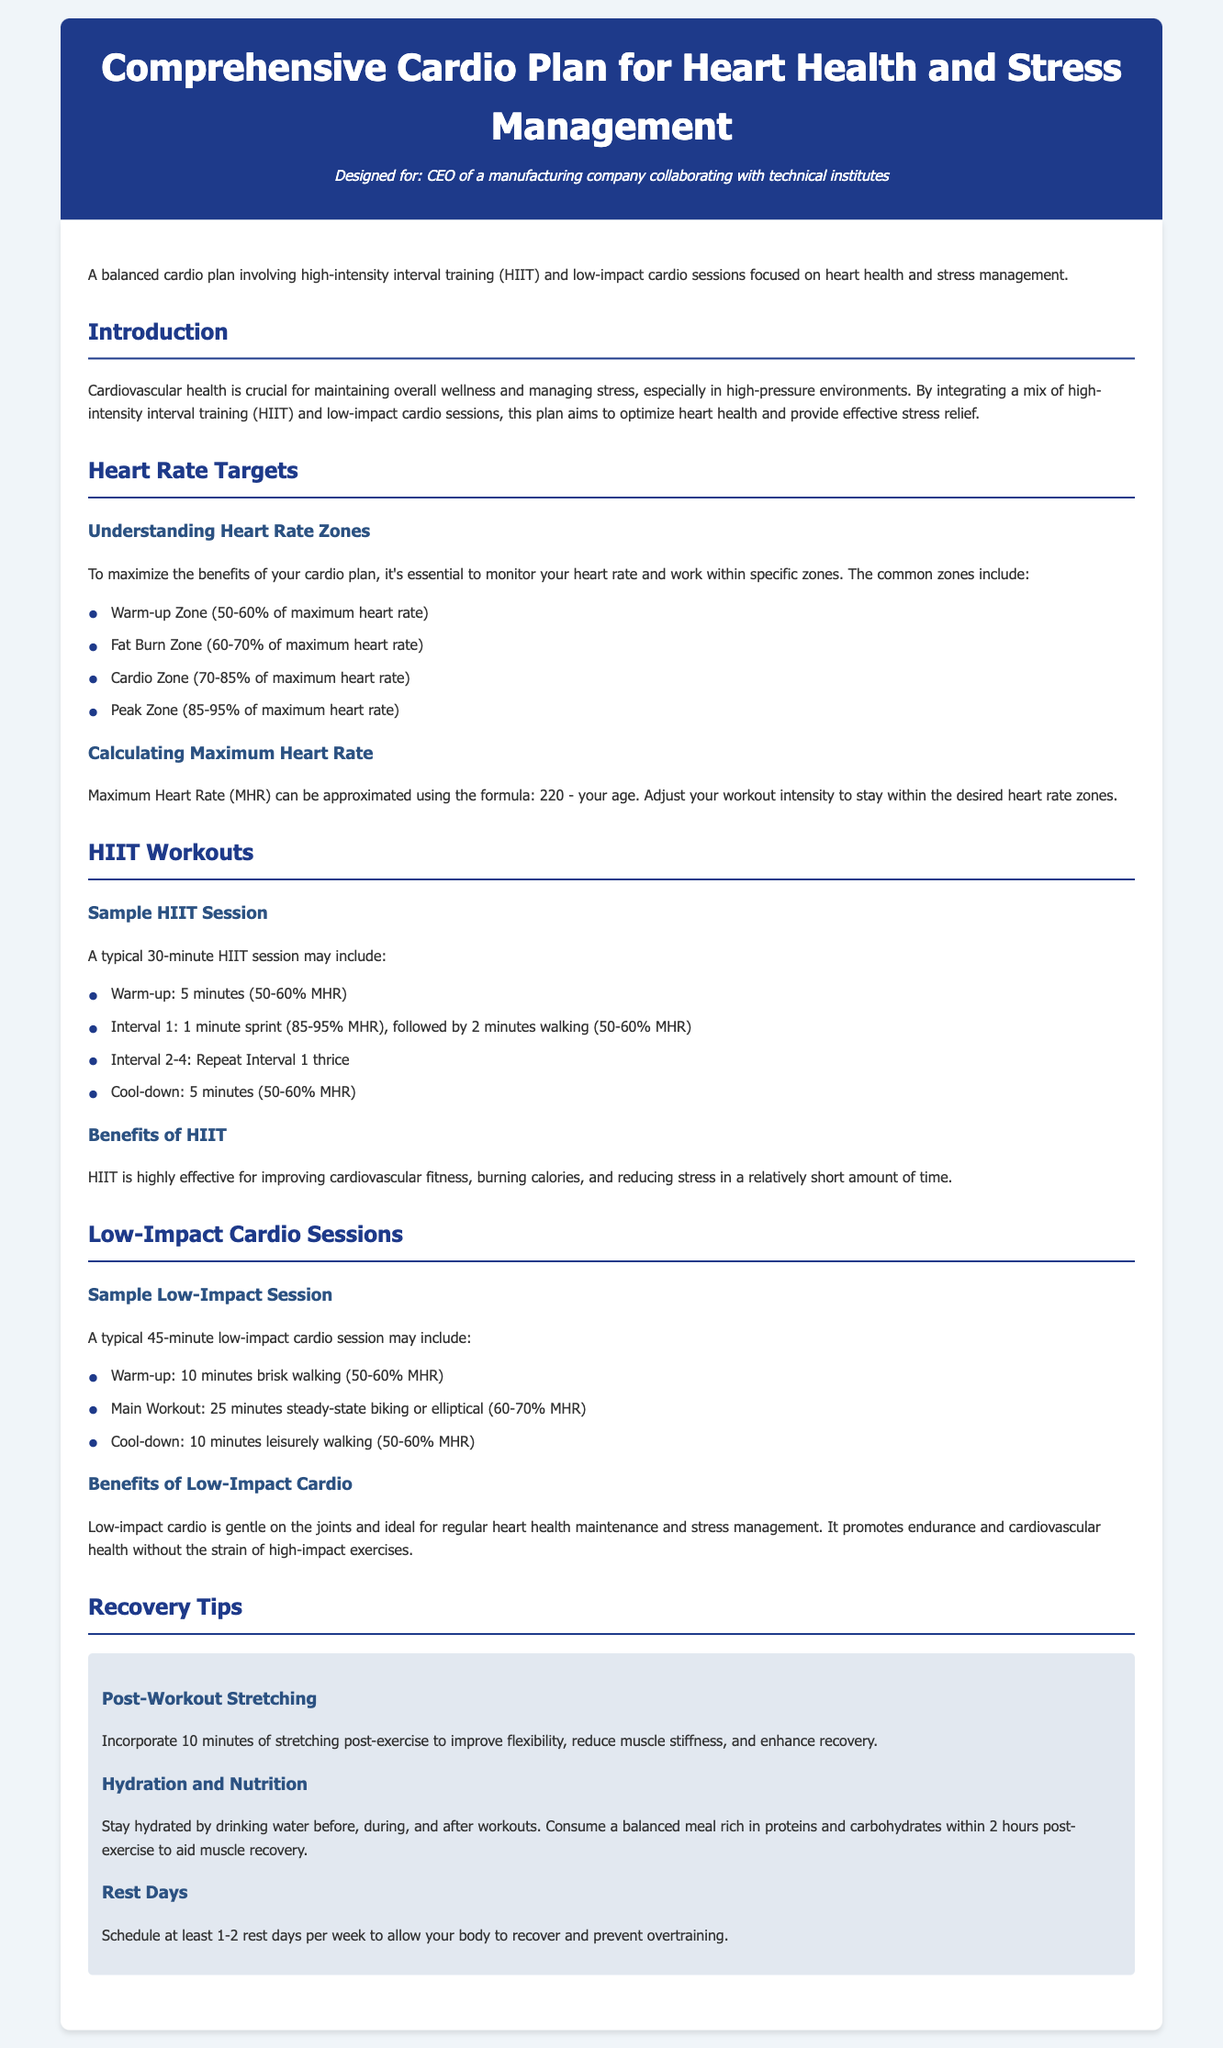What are the two main types of cardio in the plan? The document emphasizes a mix of high-intensity interval training (HIIT) and low-impact cardio sessions.
Answer: HIIT and low-impact cardio What is the maximum heart rate formula? The document states that Maximum Heart Rate can be estimated using the formula: 220 - your age.
Answer: 220 - your age What is the cool-down duration for a HIIT session? According to the document, a HIIT session includes a cool-down period of 5 minutes.
Answer: 5 minutes What percentage of maximum heart rate is the warm-up zone? The document outlines that the warm-up zone is 50-60% of maximum heart rate.
Answer: 50-60% How long should post-workout stretching be? The document recommends incorporating 10 minutes of stretching post-exercise.
Answer: 10 minutes What is a benefit of low-impact cardio mentioned in the document? The document highlights that low-impact cardio is gentle on the joints and ideal for cardiovascular health maintenance.
Answer: Gentle on the joints How many rest days should be scheduled per week? The document suggests scheduling at least 1-2 rest days per week for recovery.
Answer: 1-2 rest days What heart rate zone is focused on fat burning? According to the document, the fat burn zone is 60-70% of maximum heart rate.
Answer: 60-70% What is the main benefit of HIIT workouts? The document mentions that HIIT is highly effective for improving cardiovascular fitness and reducing stress.
Answer: Improving cardiovascular fitness 